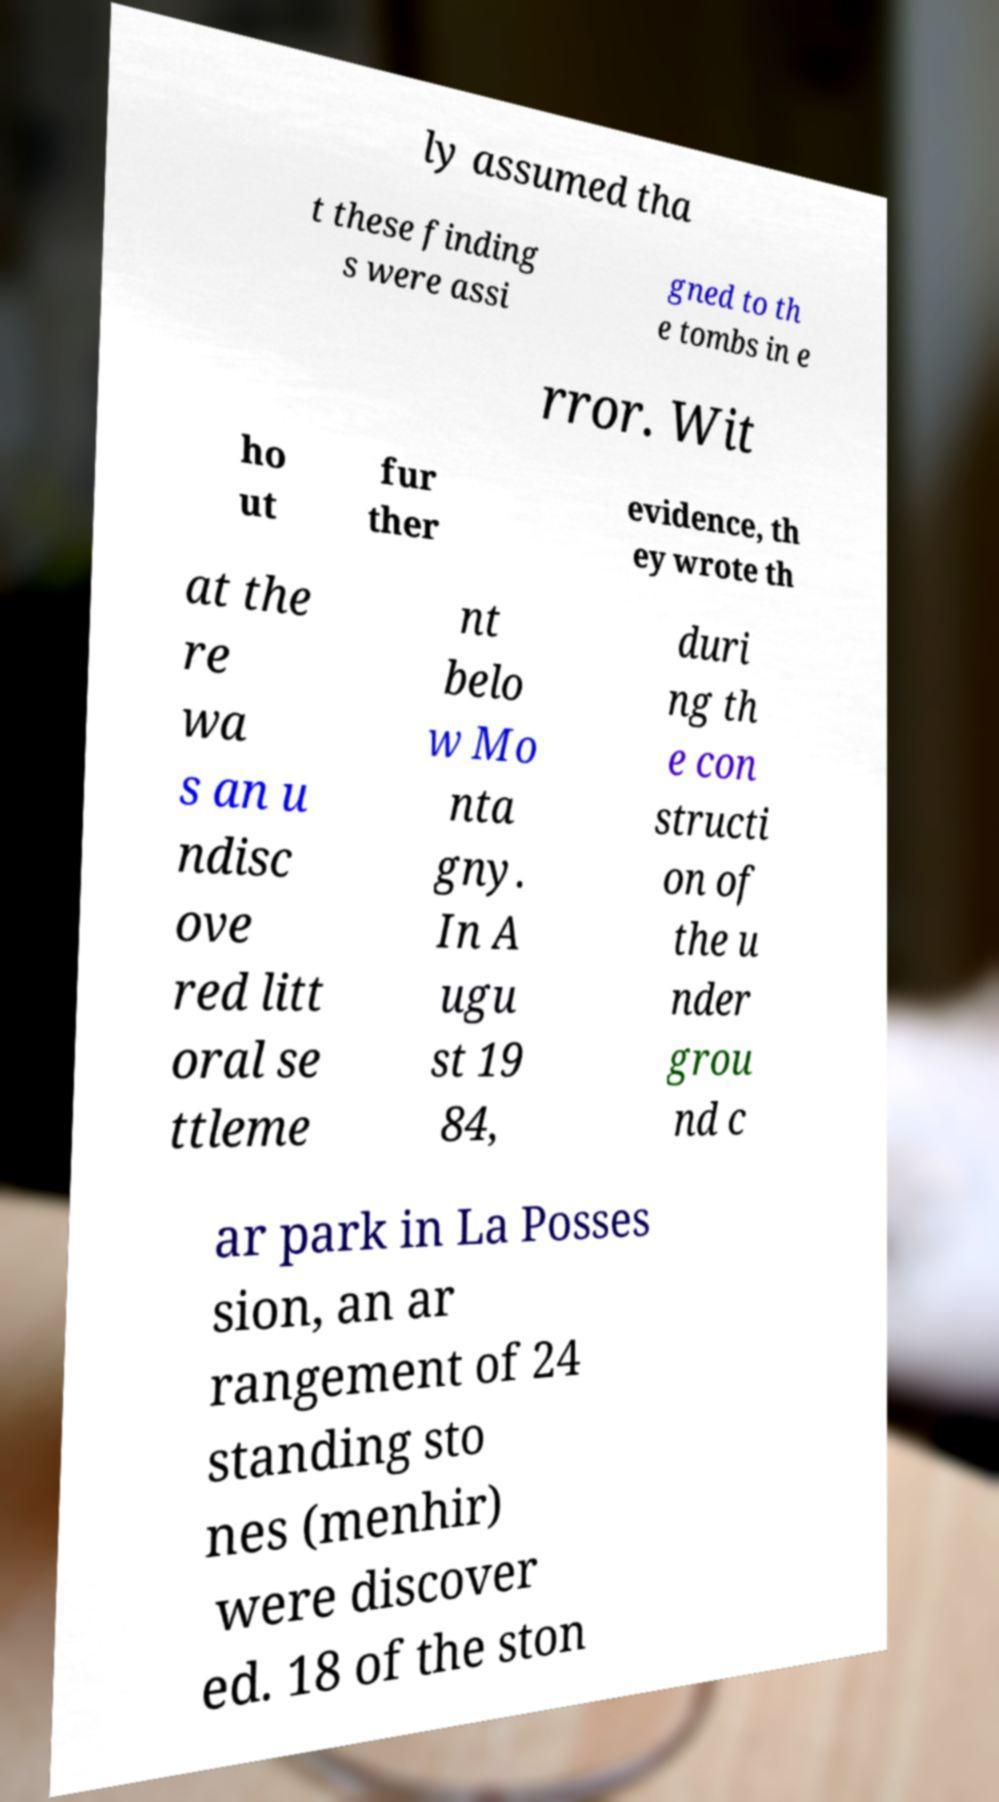Can you read and provide the text displayed in the image?This photo seems to have some interesting text. Can you extract and type it out for me? ly assumed tha t these finding s were assi gned to th e tombs in e rror. Wit ho ut fur ther evidence, th ey wrote th at the re wa s an u ndisc ove red litt oral se ttleme nt belo w Mo nta gny. In A ugu st 19 84, duri ng th e con structi on of the u nder grou nd c ar park in La Posses sion, an ar rangement of 24 standing sto nes (menhir) were discover ed. 18 of the ston 